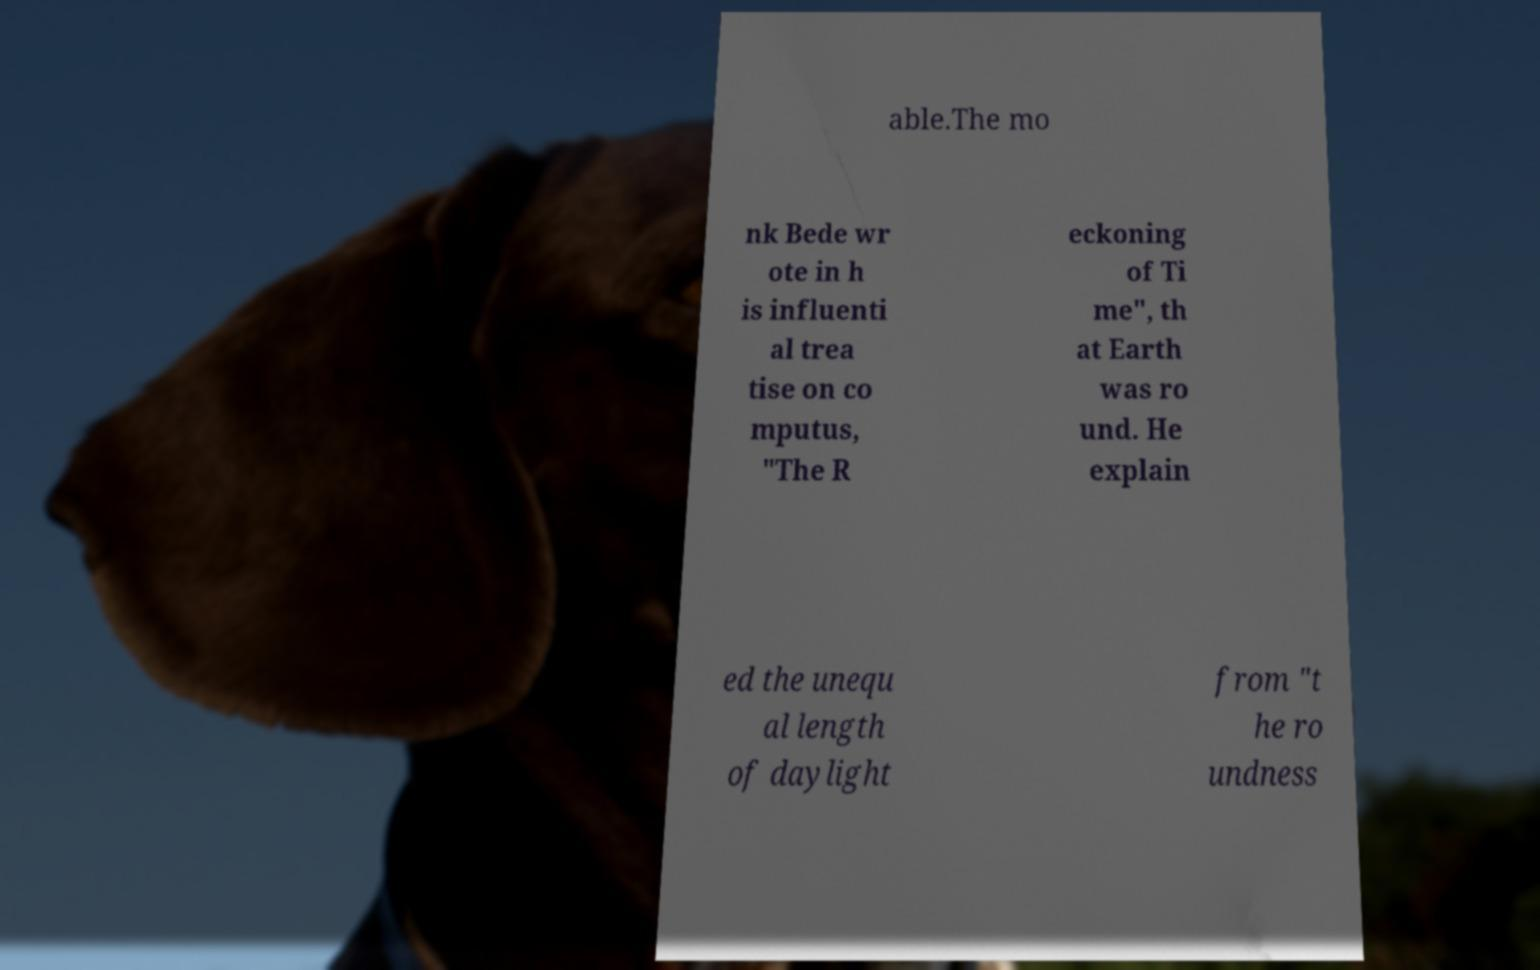I need the written content from this picture converted into text. Can you do that? able.The mo nk Bede wr ote in h is influenti al trea tise on co mputus, "The R eckoning of Ti me", th at Earth was ro und. He explain ed the unequ al length of daylight from "t he ro undness 